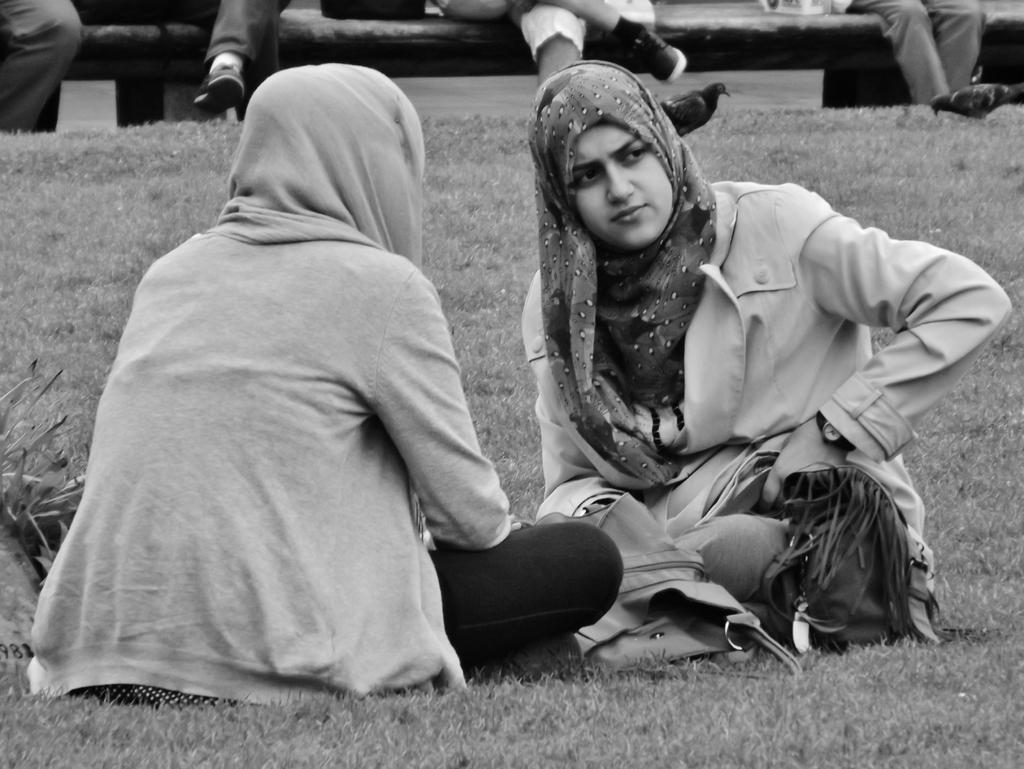Can you describe this image briefly? There are two women, facing each other and sitting on the grass on the ground. In the background, there are persons sitting on a bench. 